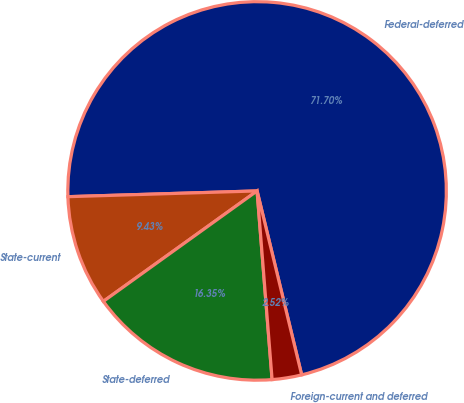Convert chart. <chart><loc_0><loc_0><loc_500><loc_500><pie_chart><fcel>Federal-deferred<fcel>State-current<fcel>State-deferred<fcel>Foreign-current and deferred<nl><fcel>71.7%<fcel>9.43%<fcel>16.35%<fcel>2.52%<nl></chart> 